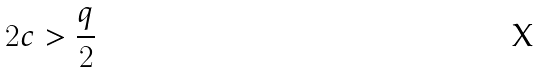<formula> <loc_0><loc_0><loc_500><loc_500>2 c > \frac { q } { 2 }</formula> 